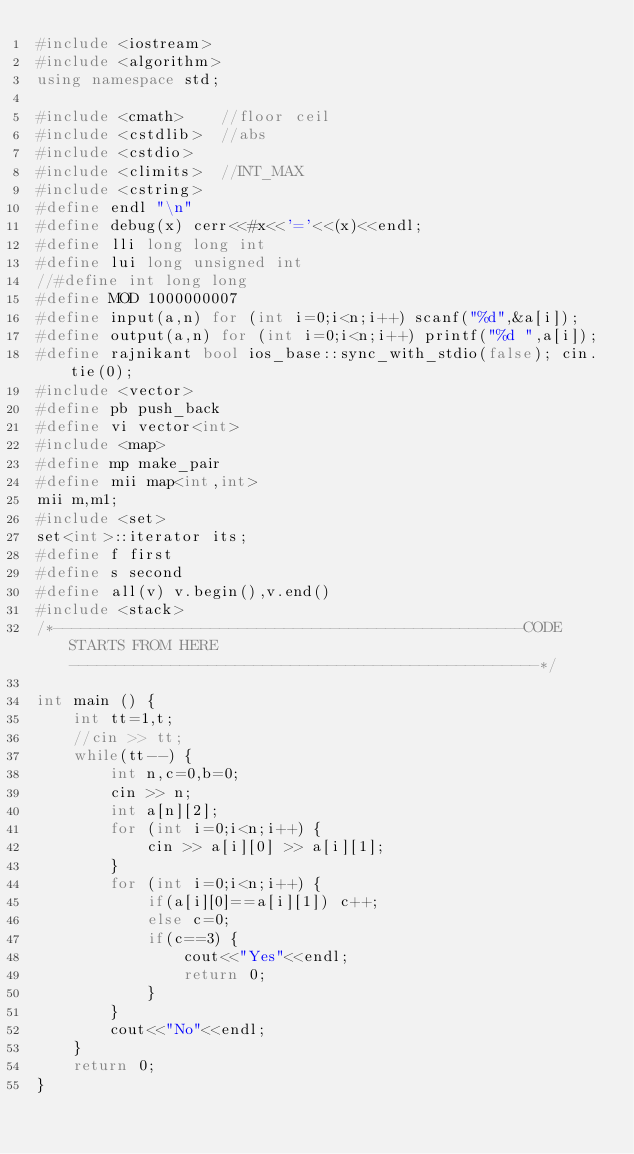<code> <loc_0><loc_0><loc_500><loc_500><_C++_>#include <iostream>
#include <algorithm>
using namespace std;

#include <cmath>    //floor ceil
#include <cstdlib>  //abs
#include <cstdio>
#include <climits>  //INT_MAX
#include <cstring>
#define endl "\n"
#define debug(x) cerr<<#x<<'='<<(x)<<endl;
#define lli long long int
#define lui long unsigned int
//#define int long long
#define MOD 1000000007
#define input(a,n) for (int i=0;i<n;i++) scanf("%d",&a[i]);
#define output(a,n) for (int i=0;i<n;i++) printf("%d ",a[i]);
#define rajnikant bool ios_base::sync_with_stdio(false); cin.tie(0);
#include <vector>
#define pb push_back
#define vi vector<int>
#include <map>
#define mp make_pair
#define mii map<int,int>
mii m,m1;
#include <set>
set<int>::iterator its;
#define f first
#define s second
#define all(v) v.begin(),v.end()
#include <stack>
/*---------------------------------------------------CODE STARTS FROM HERE---------------------------------------------------*/

int main () {
    int tt=1,t;
    //cin >> tt;
    while(tt--) {
        int n,c=0,b=0;
        cin >> n;
        int a[n][2];
        for (int i=0;i<n;i++) {
            cin >> a[i][0] >> a[i][1];
        }
        for (int i=0;i<n;i++) {
            if(a[i][0]==a[i][1]) c++;
            else c=0;
            if(c==3) {
                cout<<"Yes"<<endl;
                return 0;
            }
        }
        cout<<"No"<<endl;
    }
    return 0;
}
</code> 